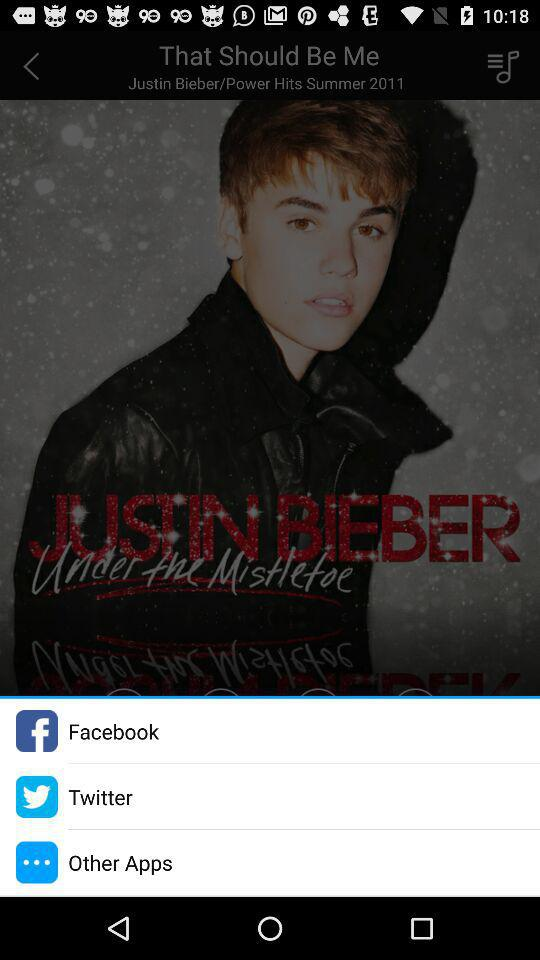Which social media options are given there? The social media options are "Facebook" and "Twitter". 